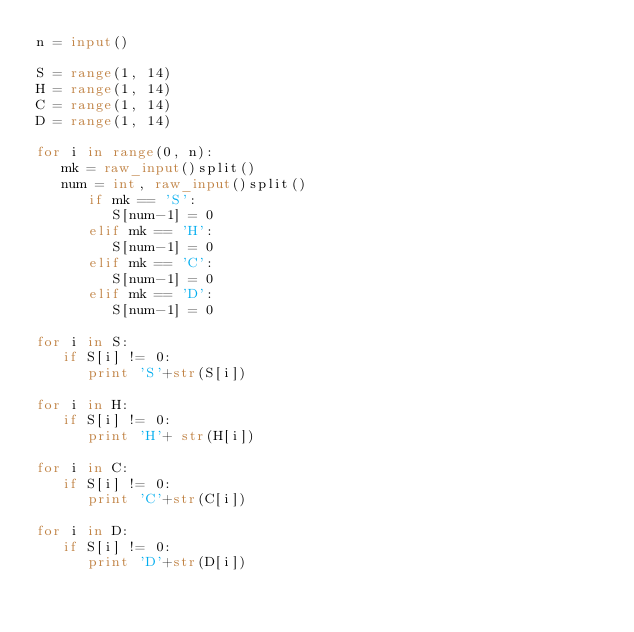Convert code to text. <code><loc_0><loc_0><loc_500><loc_500><_Python_>n = input()
    
S = range(1, 14)
H = range(1, 14)
C = range(1, 14)
D = range(1, 14)
    
for i in range(0, n):
   mk = raw_input()split()
   num = int, raw_input()split()
      if mk == 'S':
         S[num-1] = 0
      elif mk == 'H':
         S[num-1] = 0
      elif mk == 'C':
         S[num-1] = 0
      elif mk == 'D':
         S[num-1] = 0
    
for i in S:
   if S[i] != 0:
      print 'S'+str(S[i])
   
for i in H:
   if S[i] != 0:
      print 'H'+ str(H[i])
   
for i in C:
   if S[i] != 0:
      print 'C'+str(C[i])
   
for i in D:
   if S[i] != 0:
      print 'D'+str(D[i])</code> 